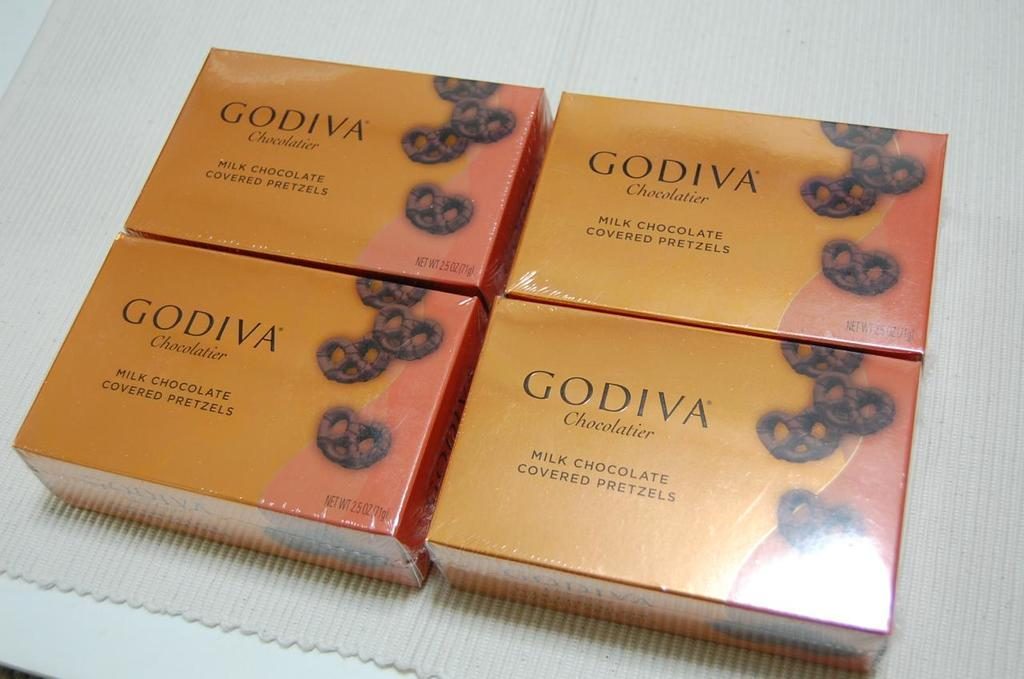<image>
Summarize the visual content of the image. Four boxes of  orange Godiva chocolate covered pretzels. 